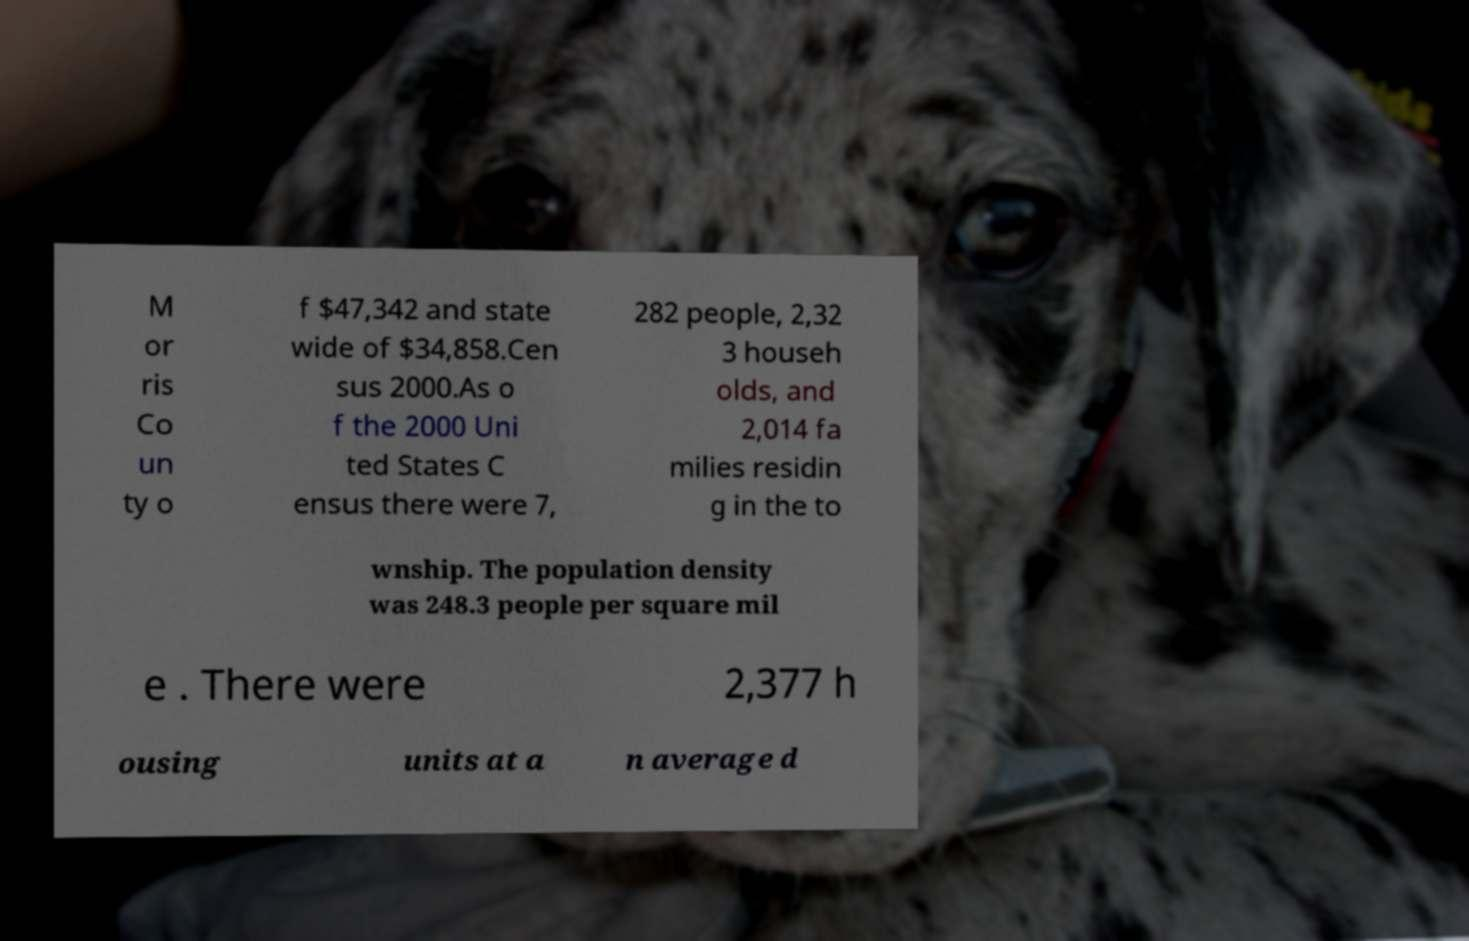Could you extract and type out the text from this image? M or ris Co un ty o f $47,342 and state wide of $34,858.Cen sus 2000.As o f the 2000 Uni ted States C ensus there were 7, 282 people, 2,32 3 househ olds, and 2,014 fa milies residin g in the to wnship. The population density was 248.3 people per square mil e . There were 2,377 h ousing units at a n average d 